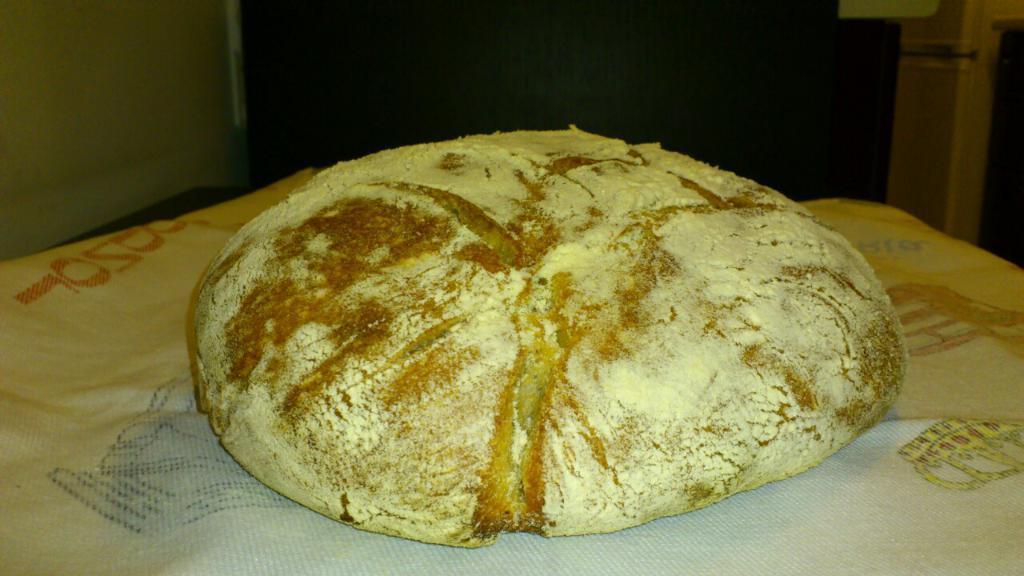How would you summarize this image in a sentence or two? In this image we can see a food item on a paper napkin, in the background, we can see the wall, and a closet. 